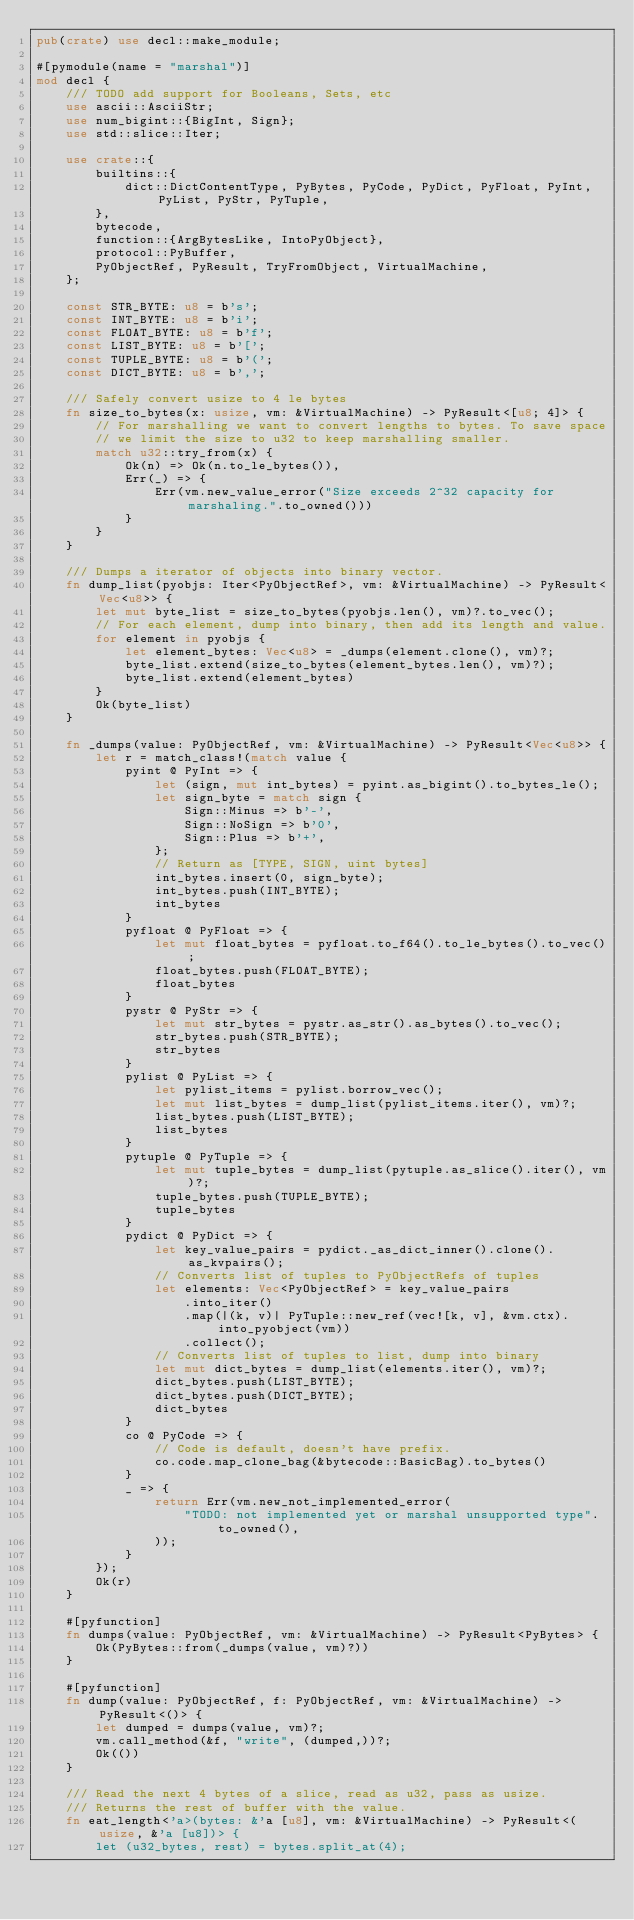Convert code to text. <code><loc_0><loc_0><loc_500><loc_500><_Rust_>pub(crate) use decl::make_module;

#[pymodule(name = "marshal")]
mod decl {
    /// TODO add support for Booleans, Sets, etc
    use ascii::AsciiStr;
    use num_bigint::{BigInt, Sign};
    use std::slice::Iter;

    use crate::{
        builtins::{
            dict::DictContentType, PyBytes, PyCode, PyDict, PyFloat, PyInt, PyList, PyStr, PyTuple,
        },
        bytecode,
        function::{ArgBytesLike, IntoPyObject},
        protocol::PyBuffer,
        PyObjectRef, PyResult, TryFromObject, VirtualMachine,
    };

    const STR_BYTE: u8 = b's';
    const INT_BYTE: u8 = b'i';
    const FLOAT_BYTE: u8 = b'f';
    const LIST_BYTE: u8 = b'[';
    const TUPLE_BYTE: u8 = b'(';
    const DICT_BYTE: u8 = b',';

    /// Safely convert usize to 4 le bytes
    fn size_to_bytes(x: usize, vm: &VirtualMachine) -> PyResult<[u8; 4]> {
        // For marshalling we want to convert lengths to bytes. To save space
        // we limit the size to u32 to keep marshalling smaller.
        match u32::try_from(x) {
            Ok(n) => Ok(n.to_le_bytes()),
            Err(_) => {
                Err(vm.new_value_error("Size exceeds 2^32 capacity for marshaling.".to_owned()))
            }
        }
    }

    /// Dumps a iterator of objects into binary vector.
    fn dump_list(pyobjs: Iter<PyObjectRef>, vm: &VirtualMachine) -> PyResult<Vec<u8>> {
        let mut byte_list = size_to_bytes(pyobjs.len(), vm)?.to_vec();
        // For each element, dump into binary, then add its length and value.
        for element in pyobjs {
            let element_bytes: Vec<u8> = _dumps(element.clone(), vm)?;
            byte_list.extend(size_to_bytes(element_bytes.len(), vm)?);
            byte_list.extend(element_bytes)
        }
        Ok(byte_list)
    }

    fn _dumps(value: PyObjectRef, vm: &VirtualMachine) -> PyResult<Vec<u8>> {
        let r = match_class!(match value {
            pyint @ PyInt => {
                let (sign, mut int_bytes) = pyint.as_bigint().to_bytes_le();
                let sign_byte = match sign {
                    Sign::Minus => b'-',
                    Sign::NoSign => b'0',
                    Sign::Plus => b'+',
                };
                // Return as [TYPE, SIGN, uint bytes]
                int_bytes.insert(0, sign_byte);
                int_bytes.push(INT_BYTE);
                int_bytes
            }
            pyfloat @ PyFloat => {
                let mut float_bytes = pyfloat.to_f64().to_le_bytes().to_vec();
                float_bytes.push(FLOAT_BYTE);
                float_bytes
            }
            pystr @ PyStr => {
                let mut str_bytes = pystr.as_str().as_bytes().to_vec();
                str_bytes.push(STR_BYTE);
                str_bytes
            }
            pylist @ PyList => {
                let pylist_items = pylist.borrow_vec();
                let mut list_bytes = dump_list(pylist_items.iter(), vm)?;
                list_bytes.push(LIST_BYTE);
                list_bytes
            }
            pytuple @ PyTuple => {
                let mut tuple_bytes = dump_list(pytuple.as_slice().iter(), vm)?;
                tuple_bytes.push(TUPLE_BYTE);
                tuple_bytes
            }
            pydict @ PyDict => {
                let key_value_pairs = pydict._as_dict_inner().clone().as_kvpairs();
                // Converts list of tuples to PyObjectRefs of tuples
                let elements: Vec<PyObjectRef> = key_value_pairs
                    .into_iter()
                    .map(|(k, v)| PyTuple::new_ref(vec![k, v], &vm.ctx).into_pyobject(vm))
                    .collect();
                // Converts list of tuples to list, dump into binary
                let mut dict_bytes = dump_list(elements.iter(), vm)?;
                dict_bytes.push(LIST_BYTE);
                dict_bytes.push(DICT_BYTE);
                dict_bytes
            }
            co @ PyCode => {
                // Code is default, doesn't have prefix.
                co.code.map_clone_bag(&bytecode::BasicBag).to_bytes()
            }
            _ => {
                return Err(vm.new_not_implemented_error(
                    "TODO: not implemented yet or marshal unsupported type".to_owned(),
                ));
            }
        });
        Ok(r)
    }

    #[pyfunction]
    fn dumps(value: PyObjectRef, vm: &VirtualMachine) -> PyResult<PyBytes> {
        Ok(PyBytes::from(_dumps(value, vm)?))
    }

    #[pyfunction]
    fn dump(value: PyObjectRef, f: PyObjectRef, vm: &VirtualMachine) -> PyResult<()> {
        let dumped = dumps(value, vm)?;
        vm.call_method(&f, "write", (dumped,))?;
        Ok(())
    }

    /// Read the next 4 bytes of a slice, read as u32, pass as usize.
    /// Returns the rest of buffer with the value.
    fn eat_length<'a>(bytes: &'a [u8], vm: &VirtualMachine) -> PyResult<(usize, &'a [u8])> {
        let (u32_bytes, rest) = bytes.split_at(4);</code> 